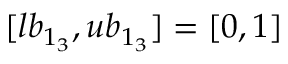Convert formula to latex. <formula><loc_0><loc_0><loc_500><loc_500>[ l b _ { 1 _ { 3 } } , u b _ { 1 _ { 3 } } ] = [ 0 , 1 ]</formula> 